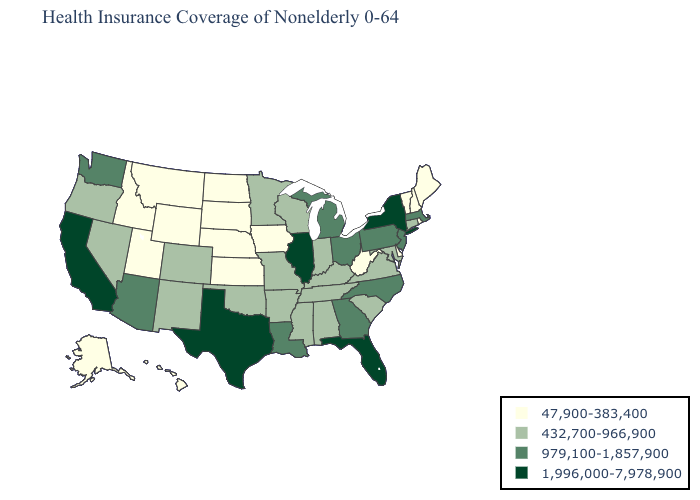What is the lowest value in the USA?
Short answer required. 47,900-383,400. Name the states that have a value in the range 47,900-383,400?
Concise answer only. Alaska, Delaware, Hawaii, Idaho, Iowa, Kansas, Maine, Montana, Nebraska, New Hampshire, North Dakota, Rhode Island, South Dakota, Utah, Vermont, West Virginia, Wyoming. Name the states that have a value in the range 979,100-1,857,900?
Answer briefly. Arizona, Georgia, Louisiana, Massachusetts, Michigan, New Jersey, North Carolina, Ohio, Pennsylvania, Washington. Which states have the highest value in the USA?
Give a very brief answer. California, Florida, Illinois, New York, Texas. What is the lowest value in the South?
Concise answer only. 47,900-383,400. Among the states that border Vermont , which have the lowest value?
Give a very brief answer. New Hampshire. Name the states that have a value in the range 979,100-1,857,900?
Answer briefly. Arizona, Georgia, Louisiana, Massachusetts, Michigan, New Jersey, North Carolina, Ohio, Pennsylvania, Washington. How many symbols are there in the legend?
Quick response, please. 4. What is the value of West Virginia?
Give a very brief answer. 47,900-383,400. Which states have the lowest value in the USA?
Answer briefly. Alaska, Delaware, Hawaii, Idaho, Iowa, Kansas, Maine, Montana, Nebraska, New Hampshire, North Dakota, Rhode Island, South Dakota, Utah, Vermont, West Virginia, Wyoming. Does West Virginia have the lowest value in the USA?
Be succinct. Yes. Among the states that border Iowa , does Illinois have the lowest value?
Quick response, please. No. Does Indiana have the same value as South Carolina?
Quick response, please. Yes. What is the value of Arizona?
Be succinct. 979,100-1,857,900. What is the highest value in the Northeast ?
Concise answer only. 1,996,000-7,978,900. 